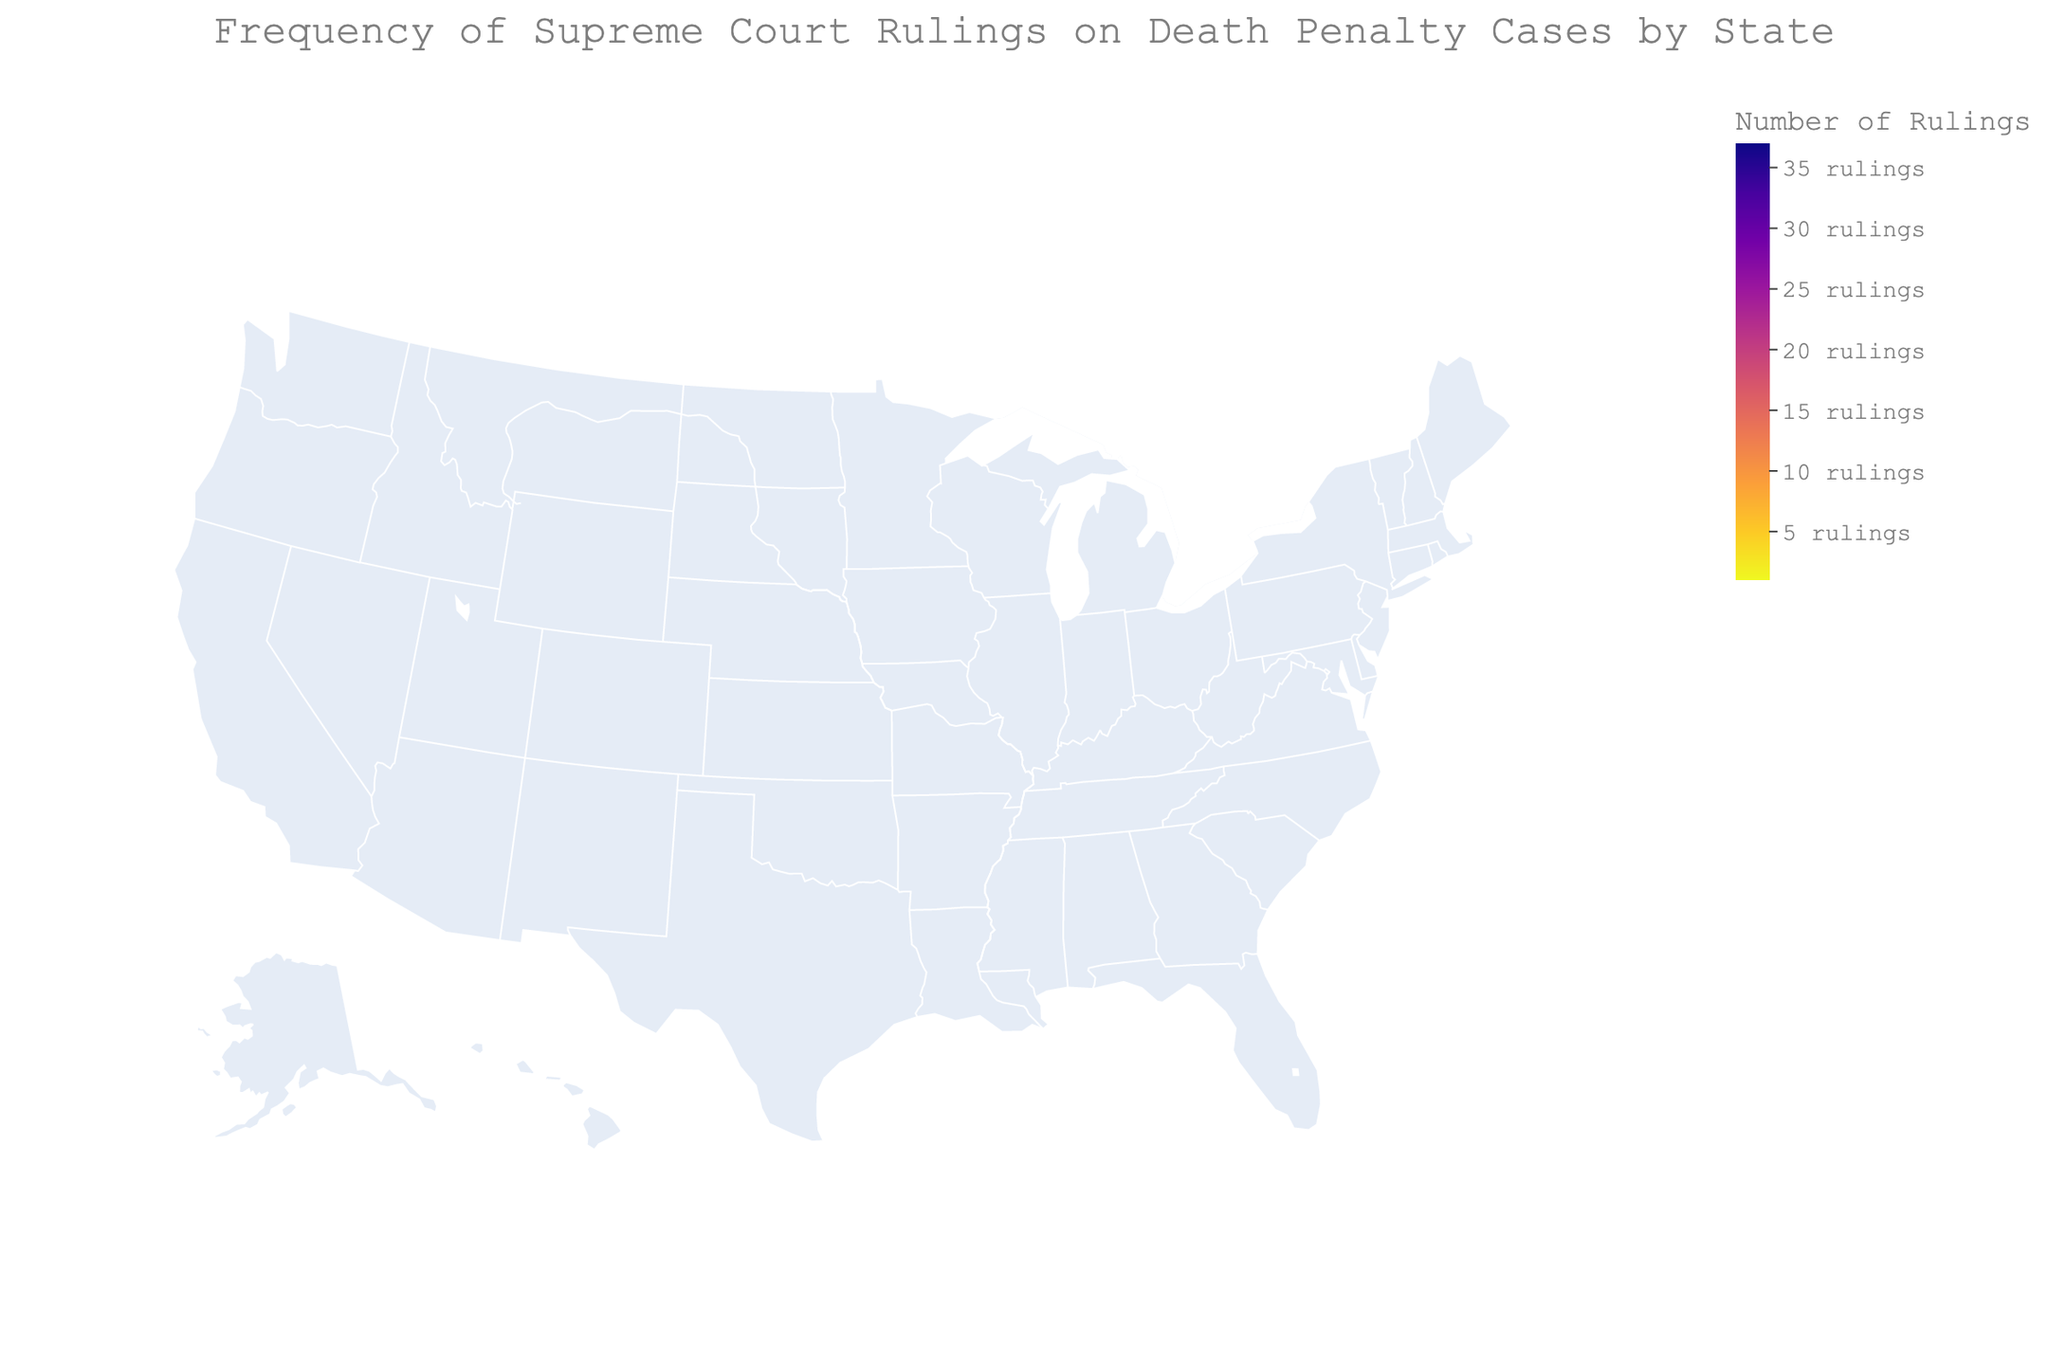What's the title of the figure? The title is typically positioned at the top center of the figure. Observing it can provide context about the data.
Answer: Frequency of Supreme Court Rulings on Death Penalty Cases by State Which state has the highest number of Supreme Court rulings on death penalty cases? By examining the color intensity on the map and using hover-over data, we can see which state has the highest frequency. Texas is depicted with the darkest color indicating the highest count.
Answer: Texas How many Supreme Court rulings on death penalty cases has California had? Hovering over California on the map will display the number of rulings.
Answer: 29 Compare the number of Supreme Court rulings on death penalty cases between Florida and Georgia. By hovering over both states on the figure, we see the specific numbers and can compare them. Florida has 25 rulings while Georgia has 18.
Answer: Florida has 7 more rulings than Georgia What is the total number of Supreme Court rulings on death penalty cases for the top three states? Summing the rulings from Texas (37), California (29), and Florida (25) gives us the total for the top three states.
Answer: 91 Which states have fewer than 5 Supreme Court rulings on death penalty cases? Hovering over each state or examining the color intensity, we identify the lighter-colored states and verify that Idaho, Illinois, Maryland, Nebraska, Oregon, Utah, Arkansas, Delaware, Indiana, and Pennsylvania each have less than 5 rulings.
Answer: Idaho, Illinois, Maryland, Nebraska, Oregon, Utah, Arkansas, Delaware, Indiana, Pennsylvania What is the average number of Supreme Court rulings on death penalty cases across all the states listed? Sum all the rulings (225) and divide by the number of states listed (28). Calculation: 225/28 = 8.04 (approximately).
Answer: 8.04 How many states have exactly 2 Supreme Court rulings on death penalty cases, and which are they? By examining the exact counts on the map, we see that there are five states with exactly 2 rulings: Arkansas, Delaware, Indiana, Pennsylvania, and Washington.
Answer: 5 states: Arkansas, Delaware, Indiana, Pennsylvania, Washington 